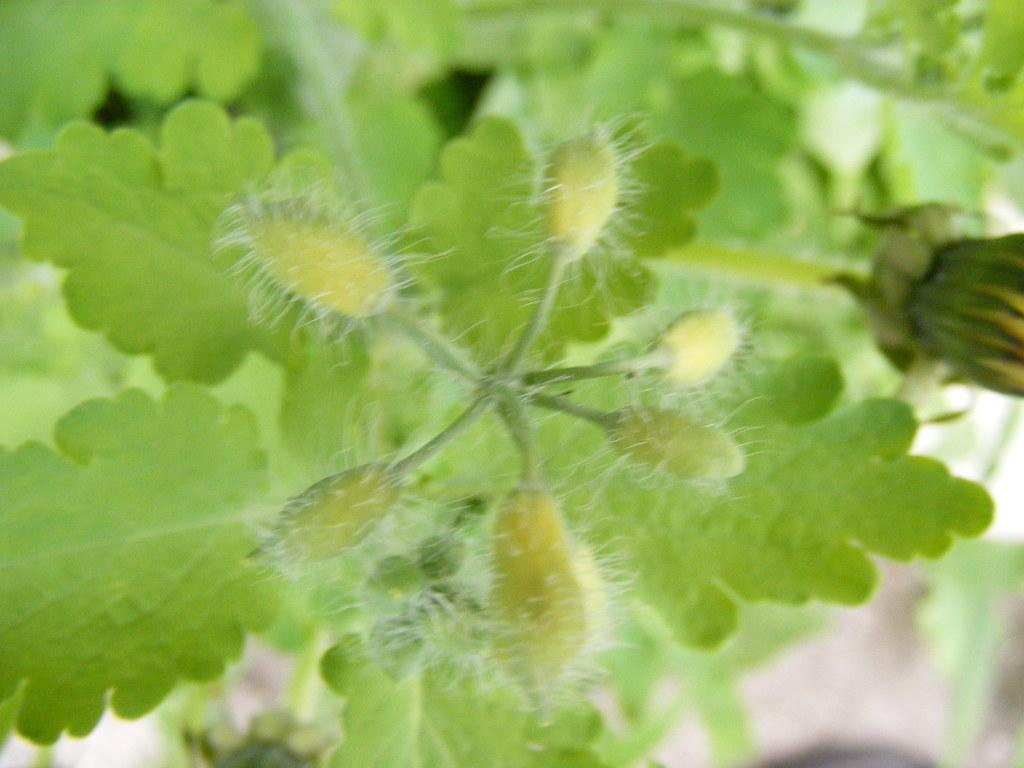What type of plant material can be seen in the image? There are leaves in the image. What stage of growth can be observed in the image? There are buds in the image. What type of pencil can be seen in the image? There is no pencil present in the image. How does the quilt look in the image? There is no quilt present in the image. 